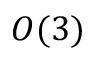<formula> <loc_0><loc_0><loc_500><loc_500>O ( 3 )</formula> 